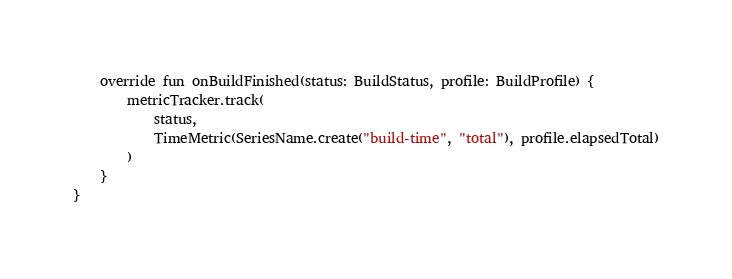<code> <loc_0><loc_0><loc_500><loc_500><_Kotlin_>
    override fun onBuildFinished(status: BuildStatus, profile: BuildProfile) {
        metricTracker.track(
            status,
            TimeMetric(SeriesName.create("build-time", "total"), profile.elapsedTotal)
        )
    }
}
</code> 